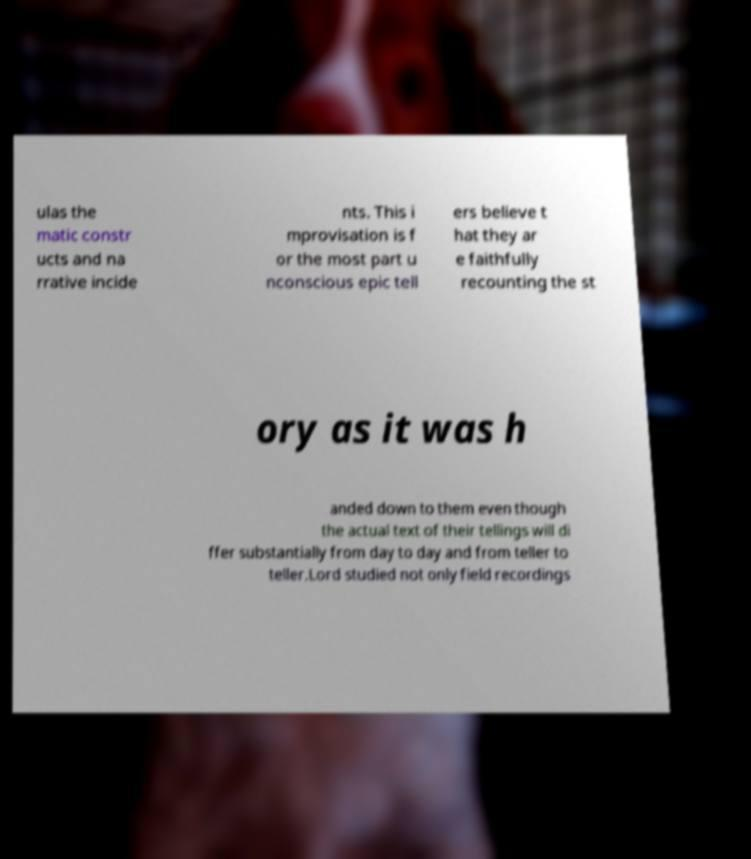Could you extract and type out the text from this image? ulas the matic constr ucts and na rrative incide nts. This i mprovisation is f or the most part u nconscious epic tell ers believe t hat they ar e faithfully recounting the st ory as it was h anded down to them even though the actual text of their tellings will di ffer substantially from day to day and from teller to teller.Lord studied not only field recordings 